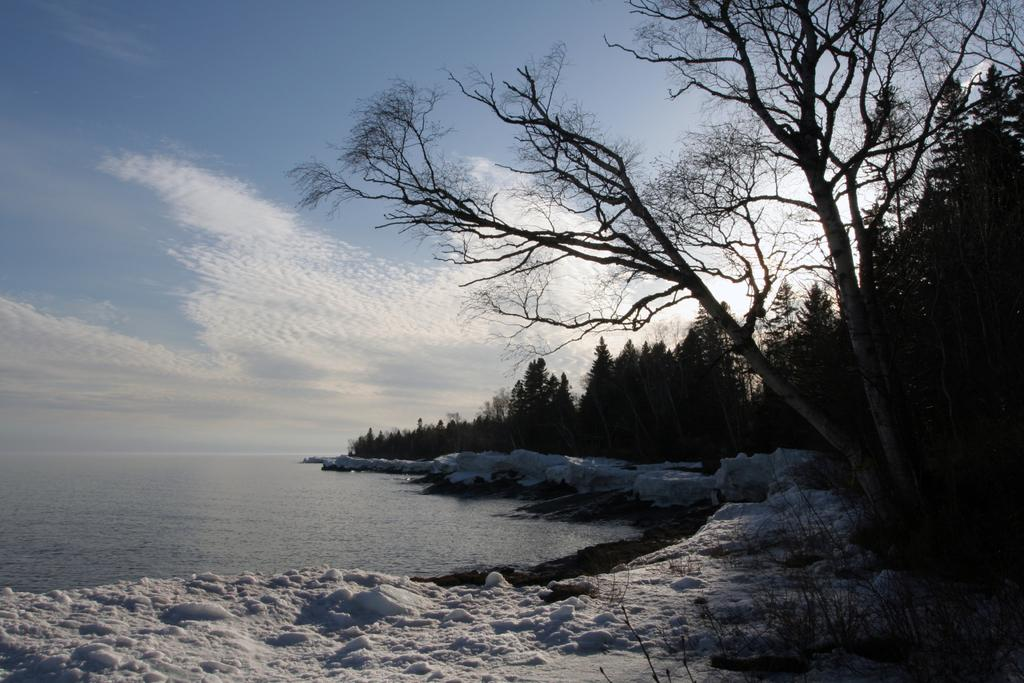What can be seen on the left side of the image? There is water on the left side of the image. What is located on the right side of the image? There are trees on the right side of the image. What type of weather condition is depicted at the bottom of the image? There is snow at the bottom side of the image. Can you see a ladybug smiling in the image? There is no ladybug or any indication of a smile in the image. 